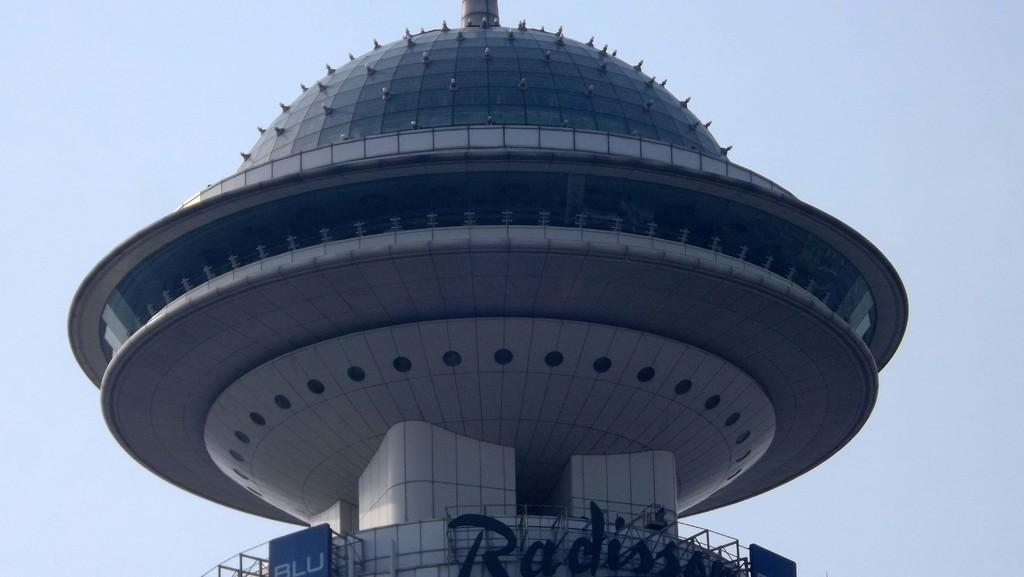What type of structure is present in the image? There is a building in the image. What can be seen in the background of the image? The sky is visible in the background of the image. How many babies are sleeping in the tent in the image? There is no tent or babies present in the image; it only features a building and the sky. What is the condition of the person's throat in the image? There is no person or mention of a throat in the image; it only features a building and the sky. 